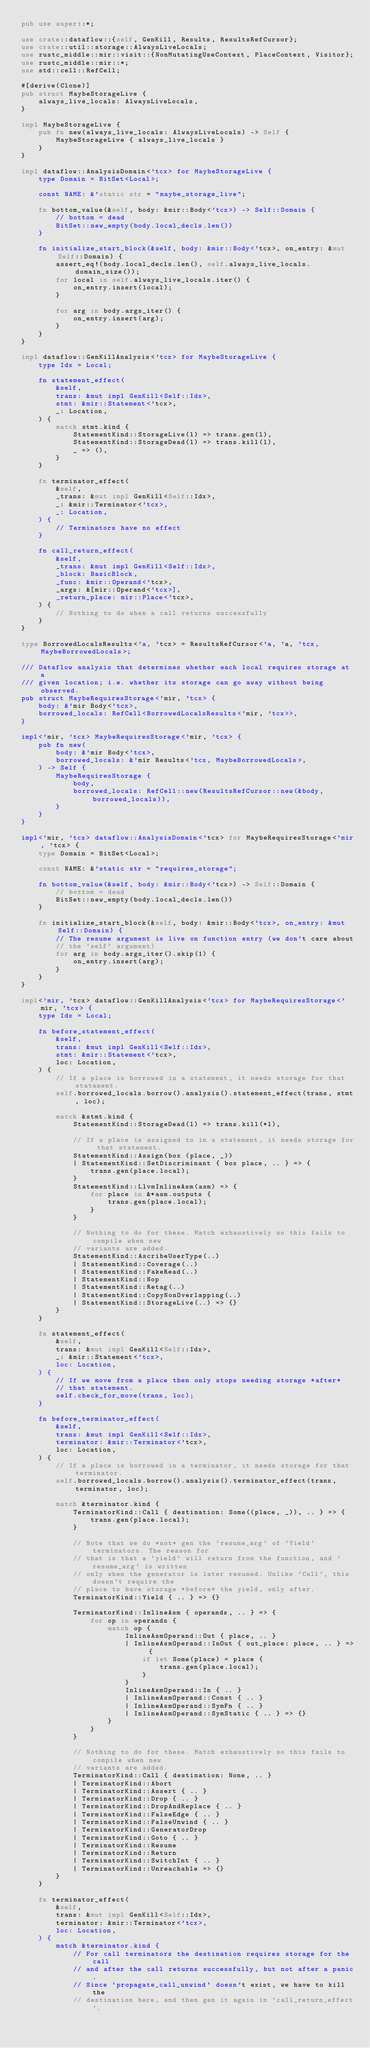<code> <loc_0><loc_0><loc_500><loc_500><_Rust_>pub use super::*;

use crate::dataflow::{self, GenKill, Results, ResultsRefCursor};
use crate::util::storage::AlwaysLiveLocals;
use rustc_middle::mir::visit::{NonMutatingUseContext, PlaceContext, Visitor};
use rustc_middle::mir::*;
use std::cell::RefCell;

#[derive(Clone)]
pub struct MaybeStorageLive {
    always_live_locals: AlwaysLiveLocals,
}

impl MaybeStorageLive {
    pub fn new(always_live_locals: AlwaysLiveLocals) -> Self {
        MaybeStorageLive { always_live_locals }
    }
}

impl dataflow::AnalysisDomain<'tcx> for MaybeStorageLive {
    type Domain = BitSet<Local>;

    const NAME: &'static str = "maybe_storage_live";

    fn bottom_value(&self, body: &mir::Body<'tcx>) -> Self::Domain {
        // bottom = dead
        BitSet::new_empty(body.local_decls.len())
    }

    fn initialize_start_block(&self, body: &mir::Body<'tcx>, on_entry: &mut Self::Domain) {
        assert_eq!(body.local_decls.len(), self.always_live_locals.domain_size());
        for local in self.always_live_locals.iter() {
            on_entry.insert(local);
        }

        for arg in body.args_iter() {
            on_entry.insert(arg);
        }
    }
}

impl dataflow::GenKillAnalysis<'tcx> for MaybeStorageLive {
    type Idx = Local;

    fn statement_effect(
        &self,
        trans: &mut impl GenKill<Self::Idx>,
        stmt: &mir::Statement<'tcx>,
        _: Location,
    ) {
        match stmt.kind {
            StatementKind::StorageLive(l) => trans.gen(l),
            StatementKind::StorageDead(l) => trans.kill(l),
            _ => (),
        }
    }

    fn terminator_effect(
        &self,
        _trans: &mut impl GenKill<Self::Idx>,
        _: &mir::Terminator<'tcx>,
        _: Location,
    ) {
        // Terminators have no effect
    }

    fn call_return_effect(
        &self,
        _trans: &mut impl GenKill<Self::Idx>,
        _block: BasicBlock,
        _func: &mir::Operand<'tcx>,
        _args: &[mir::Operand<'tcx>],
        _return_place: mir::Place<'tcx>,
    ) {
        // Nothing to do when a call returns successfully
    }
}

type BorrowedLocalsResults<'a, 'tcx> = ResultsRefCursor<'a, 'a, 'tcx, MaybeBorrowedLocals>;

/// Dataflow analysis that determines whether each local requires storage at a
/// given location; i.e. whether its storage can go away without being observed.
pub struct MaybeRequiresStorage<'mir, 'tcx> {
    body: &'mir Body<'tcx>,
    borrowed_locals: RefCell<BorrowedLocalsResults<'mir, 'tcx>>,
}

impl<'mir, 'tcx> MaybeRequiresStorage<'mir, 'tcx> {
    pub fn new(
        body: &'mir Body<'tcx>,
        borrowed_locals: &'mir Results<'tcx, MaybeBorrowedLocals>,
    ) -> Self {
        MaybeRequiresStorage {
            body,
            borrowed_locals: RefCell::new(ResultsRefCursor::new(&body, borrowed_locals)),
        }
    }
}

impl<'mir, 'tcx> dataflow::AnalysisDomain<'tcx> for MaybeRequiresStorage<'mir, 'tcx> {
    type Domain = BitSet<Local>;

    const NAME: &'static str = "requires_storage";

    fn bottom_value(&self, body: &mir::Body<'tcx>) -> Self::Domain {
        // bottom = dead
        BitSet::new_empty(body.local_decls.len())
    }

    fn initialize_start_block(&self, body: &mir::Body<'tcx>, on_entry: &mut Self::Domain) {
        // The resume argument is live on function entry (we don't care about
        // the `self` argument)
        for arg in body.args_iter().skip(1) {
            on_entry.insert(arg);
        }
    }
}

impl<'mir, 'tcx> dataflow::GenKillAnalysis<'tcx> for MaybeRequiresStorage<'mir, 'tcx> {
    type Idx = Local;

    fn before_statement_effect(
        &self,
        trans: &mut impl GenKill<Self::Idx>,
        stmt: &mir::Statement<'tcx>,
        loc: Location,
    ) {
        // If a place is borrowed in a statement, it needs storage for that statement.
        self.borrowed_locals.borrow().analysis().statement_effect(trans, stmt, loc);

        match &stmt.kind {
            StatementKind::StorageDead(l) => trans.kill(*l),

            // If a place is assigned to in a statement, it needs storage for that statement.
            StatementKind::Assign(box (place, _))
            | StatementKind::SetDiscriminant { box place, .. } => {
                trans.gen(place.local);
            }
            StatementKind::LlvmInlineAsm(asm) => {
                for place in &*asm.outputs {
                    trans.gen(place.local);
                }
            }

            // Nothing to do for these. Match exhaustively so this fails to compile when new
            // variants are added.
            StatementKind::AscribeUserType(..)
            | StatementKind::Coverage(..)
            | StatementKind::FakeRead(..)
            | StatementKind::Nop
            | StatementKind::Retag(..)
            | StatementKind::CopyNonOverlapping(..)
            | StatementKind::StorageLive(..) => {}
        }
    }

    fn statement_effect(
        &self,
        trans: &mut impl GenKill<Self::Idx>,
        _: &mir::Statement<'tcx>,
        loc: Location,
    ) {
        // If we move from a place then only stops needing storage *after*
        // that statement.
        self.check_for_move(trans, loc);
    }

    fn before_terminator_effect(
        &self,
        trans: &mut impl GenKill<Self::Idx>,
        terminator: &mir::Terminator<'tcx>,
        loc: Location,
    ) {
        // If a place is borrowed in a terminator, it needs storage for that terminator.
        self.borrowed_locals.borrow().analysis().terminator_effect(trans, terminator, loc);

        match &terminator.kind {
            TerminatorKind::Call { destination: Some((place, _)), .. } => {
                trans.gen(place.local);
            }

            // Note that we do *not* gen the `resume_arg` of `Yield` terminators. The reason for
            // that is that a `yield` will return from the function, and `resume_arg` is written
            // only when the generator is later resumed. Unlike `Call`, this doesn't require the
            // place to have storage *before* the yield, only after.
            TerminatorKind::Yield { .. } => {}

            TerminatorKind::InlineAsm { operands, .. } => {
                for op in operands {
                    match op {
                        InlineAsmOperand::Out { place, .. }
                        | InlineAsmOperand::InOut { out_place: place, .. } => {
                            if let Some(place) = place {
                                trans.gen(place.local);
                            }
                        }
                        InlineAsmOperand::In { .. }
                        | InlineAsmOperand::Const { .. }
                        | InlineAsmOperand::SymFn { .. }
                        | InlineAsmOperand::SymStatic { .. } => {}
                    }
                }
            }

            // Nothing to do for these. Match exhaustively so this fails to compile when new
            // variants are added.
            TerminatorKind::Call { destination: None, .. }
            | TerminatorKind::Abort
            | TerminatorKind::Assert { .. }
            | TerminatorKind::Drop { .. }
            | TerminatorKind::DropAndReplace { .. }
            | TerminatorKind::FalseEdge { .. }
            | TerminatorKind::FalseUnwind { .. }
            | TerminatorKind::GeneratorDrop
            | TerminatorKind::Goto { .. }
            | TerminatorKind::Resume
            | TerminatorKind::Return
            | TerminatorKind::SwitchInt { .. }
            | TerminatorKind::Unreachable => {}
        }
    }

    fn terminator_effect(
        &self,
        trans: &mut impl GenKill<Self::Idx>,
        terminator: &mir::Terminator<'tcx>,
        loc: Location,
    ) {
        match &terminator.kind {
            // For call terminators the destination requires storage for the call
            // and after the call returns successfully, but not after a panic.
            // Since `propagate_call_unwind` doesn't exist, we have to kill the
            // destination here, and then gen it again in `call_return_effect`.</code> 